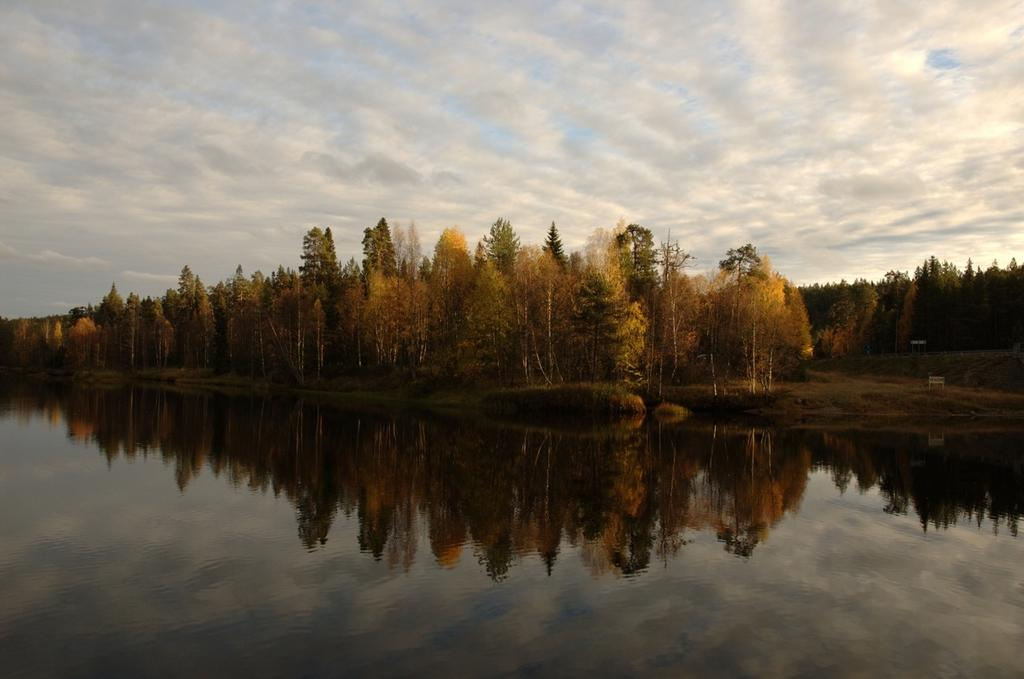What is the main element in the image? There is water in the image. What can be seen in the water due to its reflective properties? The reflection of trees is visible in the water. What type of vegetation is located near the water? There are trees beside the water. How would you describe the sky in the image? The sky is clear in the image. Can you tell me how many rings are visible on the partner's finger in the image? There are no people or rings present in the image; it features water with the reflection of trees and trees beside the water. 